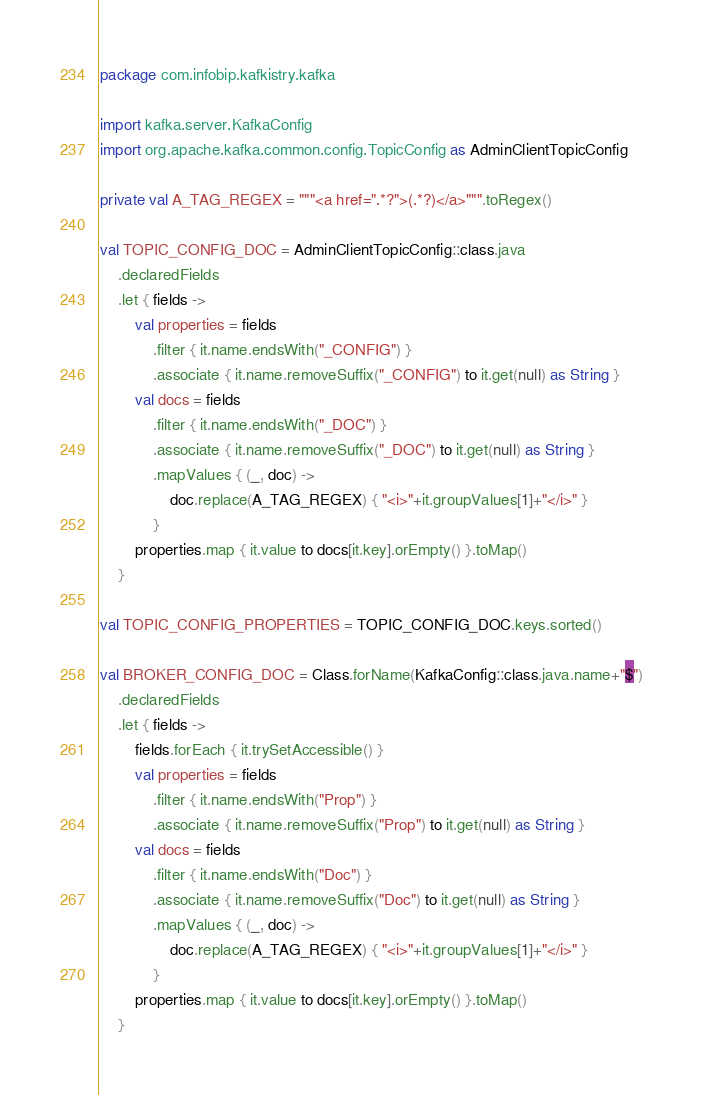Convert code to text. <code><loc_0><loc_0><loc_500><loc_500><_Kotlin_>package com.infobip.kafkistry.kafka

import kafka.server.KafkaConfig
import org.apache.kafka.common.config.TopicConfig as AdminClientTopicConfig

private val A_TAG_REGEX = """<a href=".*?">(.*?)</a>""".toRegex()

val TOPIC_CONFIG_DOC = AdminClientTopicConfig::class.java
    .declaredFields
    .let { fields ->
        val properties = fields
            .filter { it.name.endsWith("_CONFIG") }
            .associate { it.name.removeSuffix("_CONFIG") to it.get(null) as String }
        val docs = fields
            .filter { it.name.endsWith("_DOC") }
            .associate { it.name.removeSuffix("_DOC") to it.get(null) as String }
            .mapValues { (_, doc) ->
                doc.replace(A_TAG_REGEX) { "<i>"+it.groupValues[1]+"</i>" }
            }
        properties.map { it.value to docs[it.key].orEmpty() }.toMap()
    }

val TOPIC_CONFIG_PROPERTIES = TOPIC_CONFIG_DOC.keys.sorted()

val BROKER_CONFIG_DOC = Class.forName(KafkaConfig::class.java.name+"$")
    .declaredFields
    .let { fields ->
        fields.forEach { it.trySetAccessible() }
        val properties = fields
            .filter { it.name.endsWith("Prop") }
            .associate { it.name.removeSuffix("Prop") to it.get(null) as String }
        val docs = fields
            .filter { it.name.endsWith("Doc") }
            .associate { it.name.removeSuffix("Doc") to it.get(null) as String }
            .mapValues { (_, doc) ->
                doc.replace(A_TAG_REGEX) { "<i>"+it.groupValues[1]+"</i>" }
            }
        properties.map { it.value to docs[it.key].orEmpty() }.toMap()
    }

</code> 